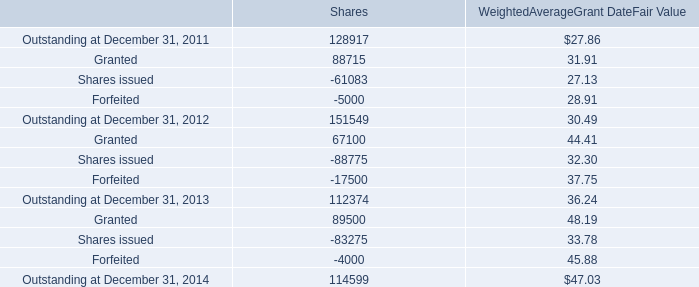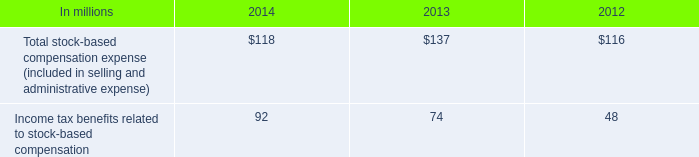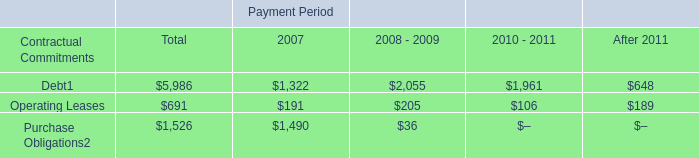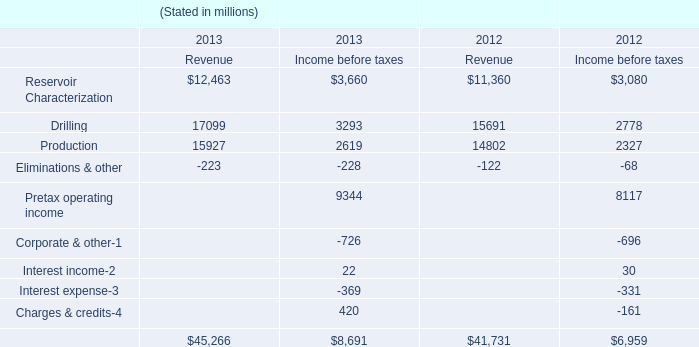What is the sum of Outstanding at December 31, 2013 of Shares, Purchase Obligations of Payment Period 2007, and Outstanding at December 31, 2014 of Shares ? 
Computations: ((112374.0 + 1490.0) + 114599.0)
Answer: 228463.0. 